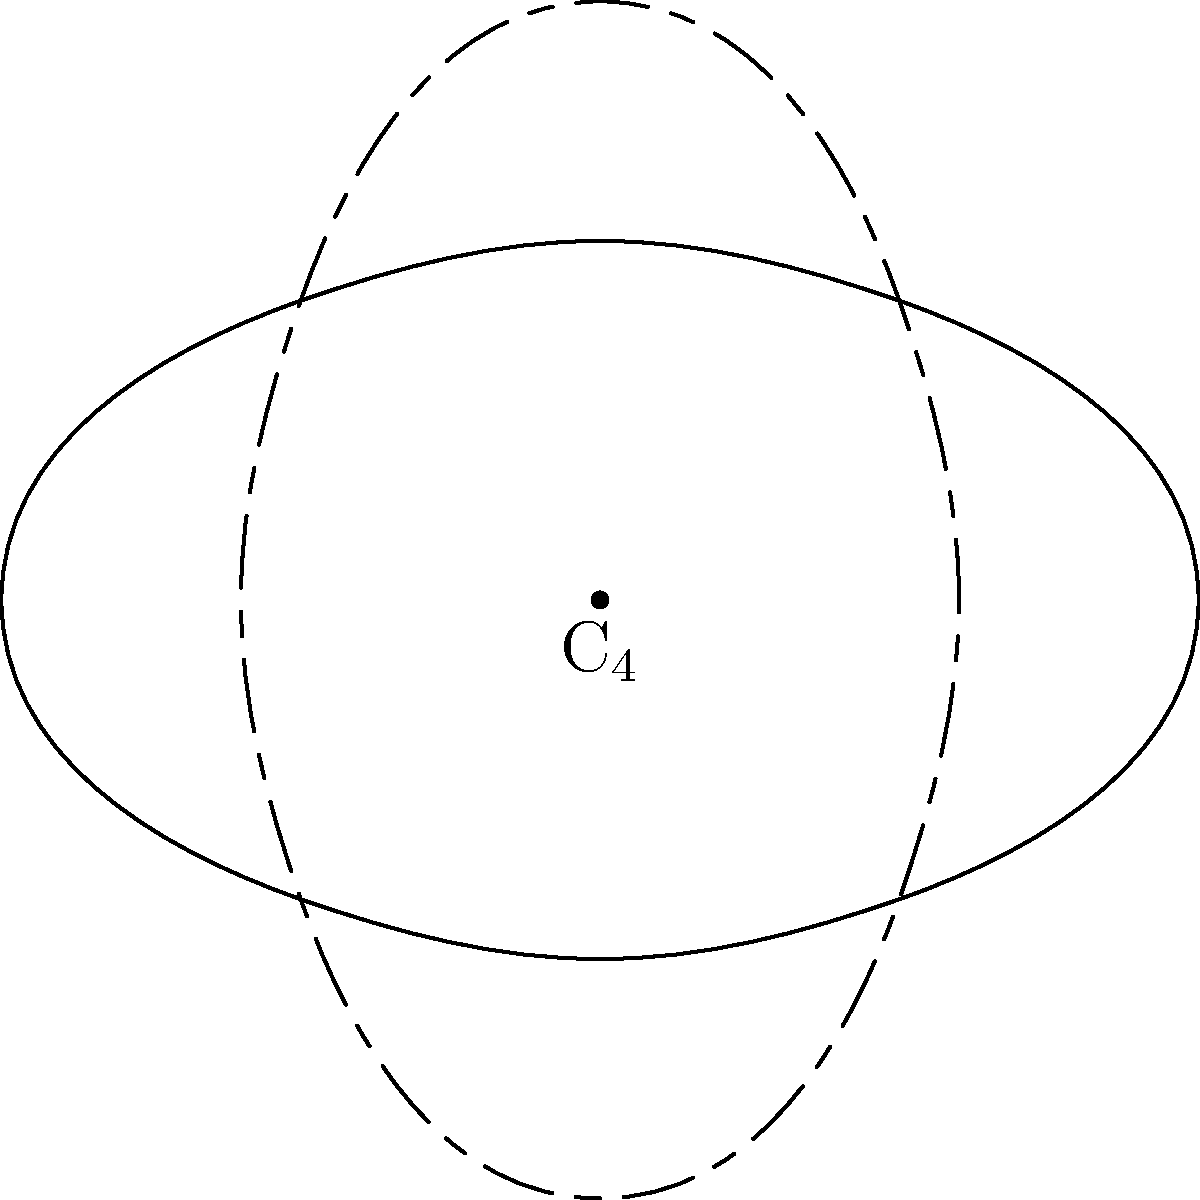Consider the simplified body shape of Copionodon pecten as shown in the diagram. Which rotation group best describes the symmetry of this fish's body shape, and what is the order of this group? To determine the rotation group and its order for the Copionodon pecten's body shape, let's follow these steps:

1. Observe the fish's body shape in the diagram. It appears to have bilateral symmetry (left-right symmetry).

2. The diagram shows rotations of 90°, 180°, and 270° around the center point.

3. We can see that a 360° rotation (or 0°) returns the fish to its original position.

4. The fish's shape looks different at 90° and 270° rotations, but similar at 180° rotation due to its bilateral symmetry.

5. This symmetry pattern corresponds to the cyclic group $C_2$, which includes rotations of 0° and 180°.

6. The order of a group is the number of elements in the group. For $C_2$, there are two elements: the identity rotation (0°) and the 180° rotation.

Therefore, the rotation group that best describes the symmetry of Copionodon pecten's body shape is $C_2$, and its order is 2.
Answer: $C_2$, order 2 